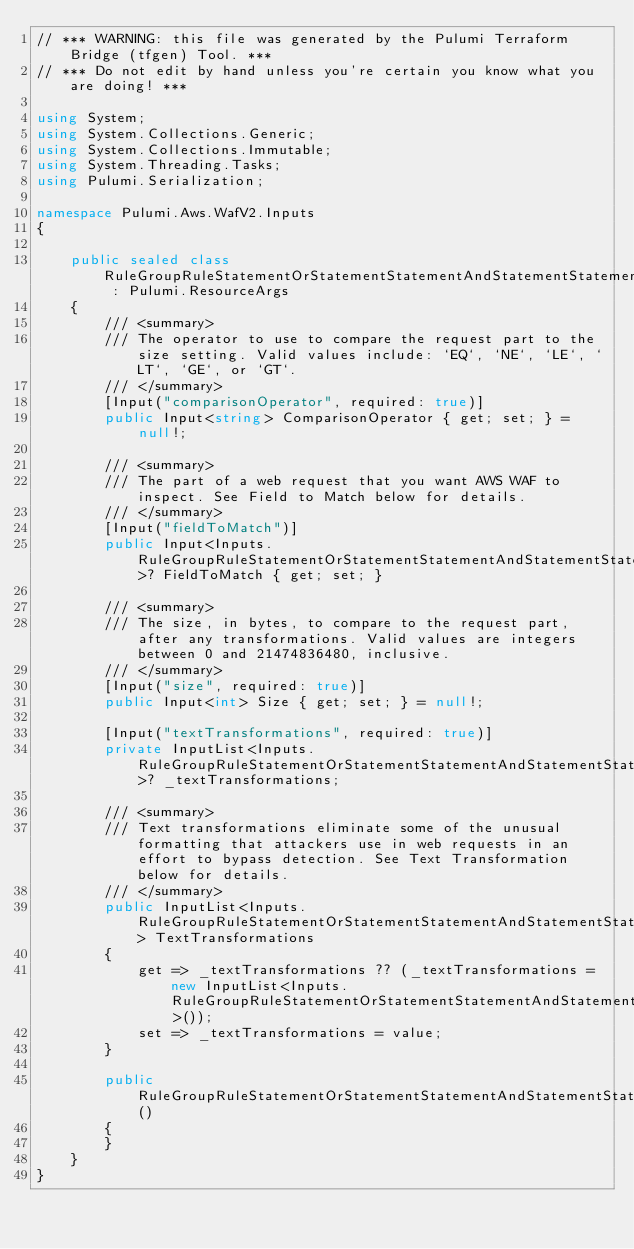<code> <loc_0><loc_0><loc_500><loc_500><_C#_>// *** WARNING: this file was generated by the Pulumi Terraform Bridge (tfgen) Tool. ***
// *** Do not edit by hand unless you're certain you know what you are doing! ***

using System;
using System.Collections.Generic;
using System.Collections.Immutable;
using System.Threading.Tasks;
using Pulumi.Serialization;

namespace Pulumi.Aws.WafV2.Inputs
{

    public sealed class RuleGroupRuleStatementOrStatementStatementAndStatementStatementSizeConstraintStatementArgs : Pulumi.ResourceArgs
    {
        /// <summary>
        /// The operator to use to compare the request part to the size setting. Valid values include: `EQ`, `NE`, `LE`, `LT`, `GE`, or `GT`.
        /// </summary>
        [Input("comparisonOperator", required: true)]
        public Input<string> ComparisonOperator { get; set; } = null!;

        /// <summary>
        /// The part of a web request that you want AWS WAF to inspect. See Field to Match below for details.
        /// </summary>
        [Input("fieldToMatch")]
        public Input<Inputs.RuleGroupRuleStatementOrStatementStatementAndStatementStatementSizeConstraintStatementFieldToMatchArgs>? FieldToMatch { get; set; }

        /// <summary>
        /// The size, in bytes, to compare to the request part, after any transformations. Valid values are integers between 0 and 21474836480, inclusive.
        /// </summary>
        [Input("size", required: true)]
        public Input<int> Size { get; set; } = null!;

        [Input("textTransformations", required: true)]
        private InputList<Inputs.RuleGroupRuleStatementOrStatementStatementAndStatementStatementSizeConstraintStatementTextTransformationArgs>? _textTransformations;

        /// <summary>
        /// Text transformations eliminate some of the unusual formatting that attackers use in web requests in an effort to bypass detection. See Text Transformation below for details.
        /// </summary>
        public InputList<Inputs.RuleGroupRuleStatementOrStatementStatementAndStatementStatementSizeConstraintStatementTextTransformationArgs> TextTransformations
        {
            get => _textTransformations ?? (_textTransformations = new InputList<Inputs.RuleGroupRuleStatementOrStatementStatementAndStatementStatementSizeConstraintStatementTextTransformationArgs>());
            set => _textTransformations = value;
        }

        public RuleGroupRuleStatementOrStatementStatementAndStatementStatementSizeConstraintStatementArgs()
        {
        }
    }
}
</code> 